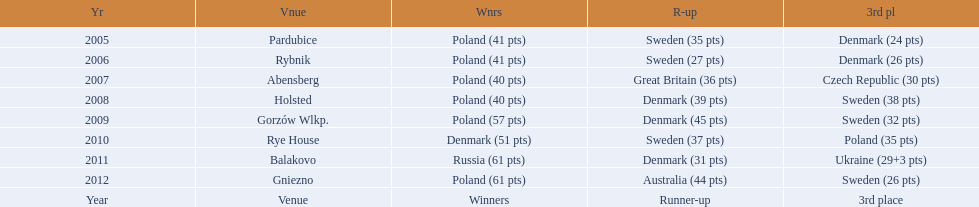In what years did denmark place in the top 3 in the team speedway junior world championship? 2005, 2006, 2008, 2009, 2010, 2011. What in what year did denmark come withing 2 points of placing higher in the standings? 2006. What place did denmark receive the year they missed higher ranking by only 2 points? 3rd place. 